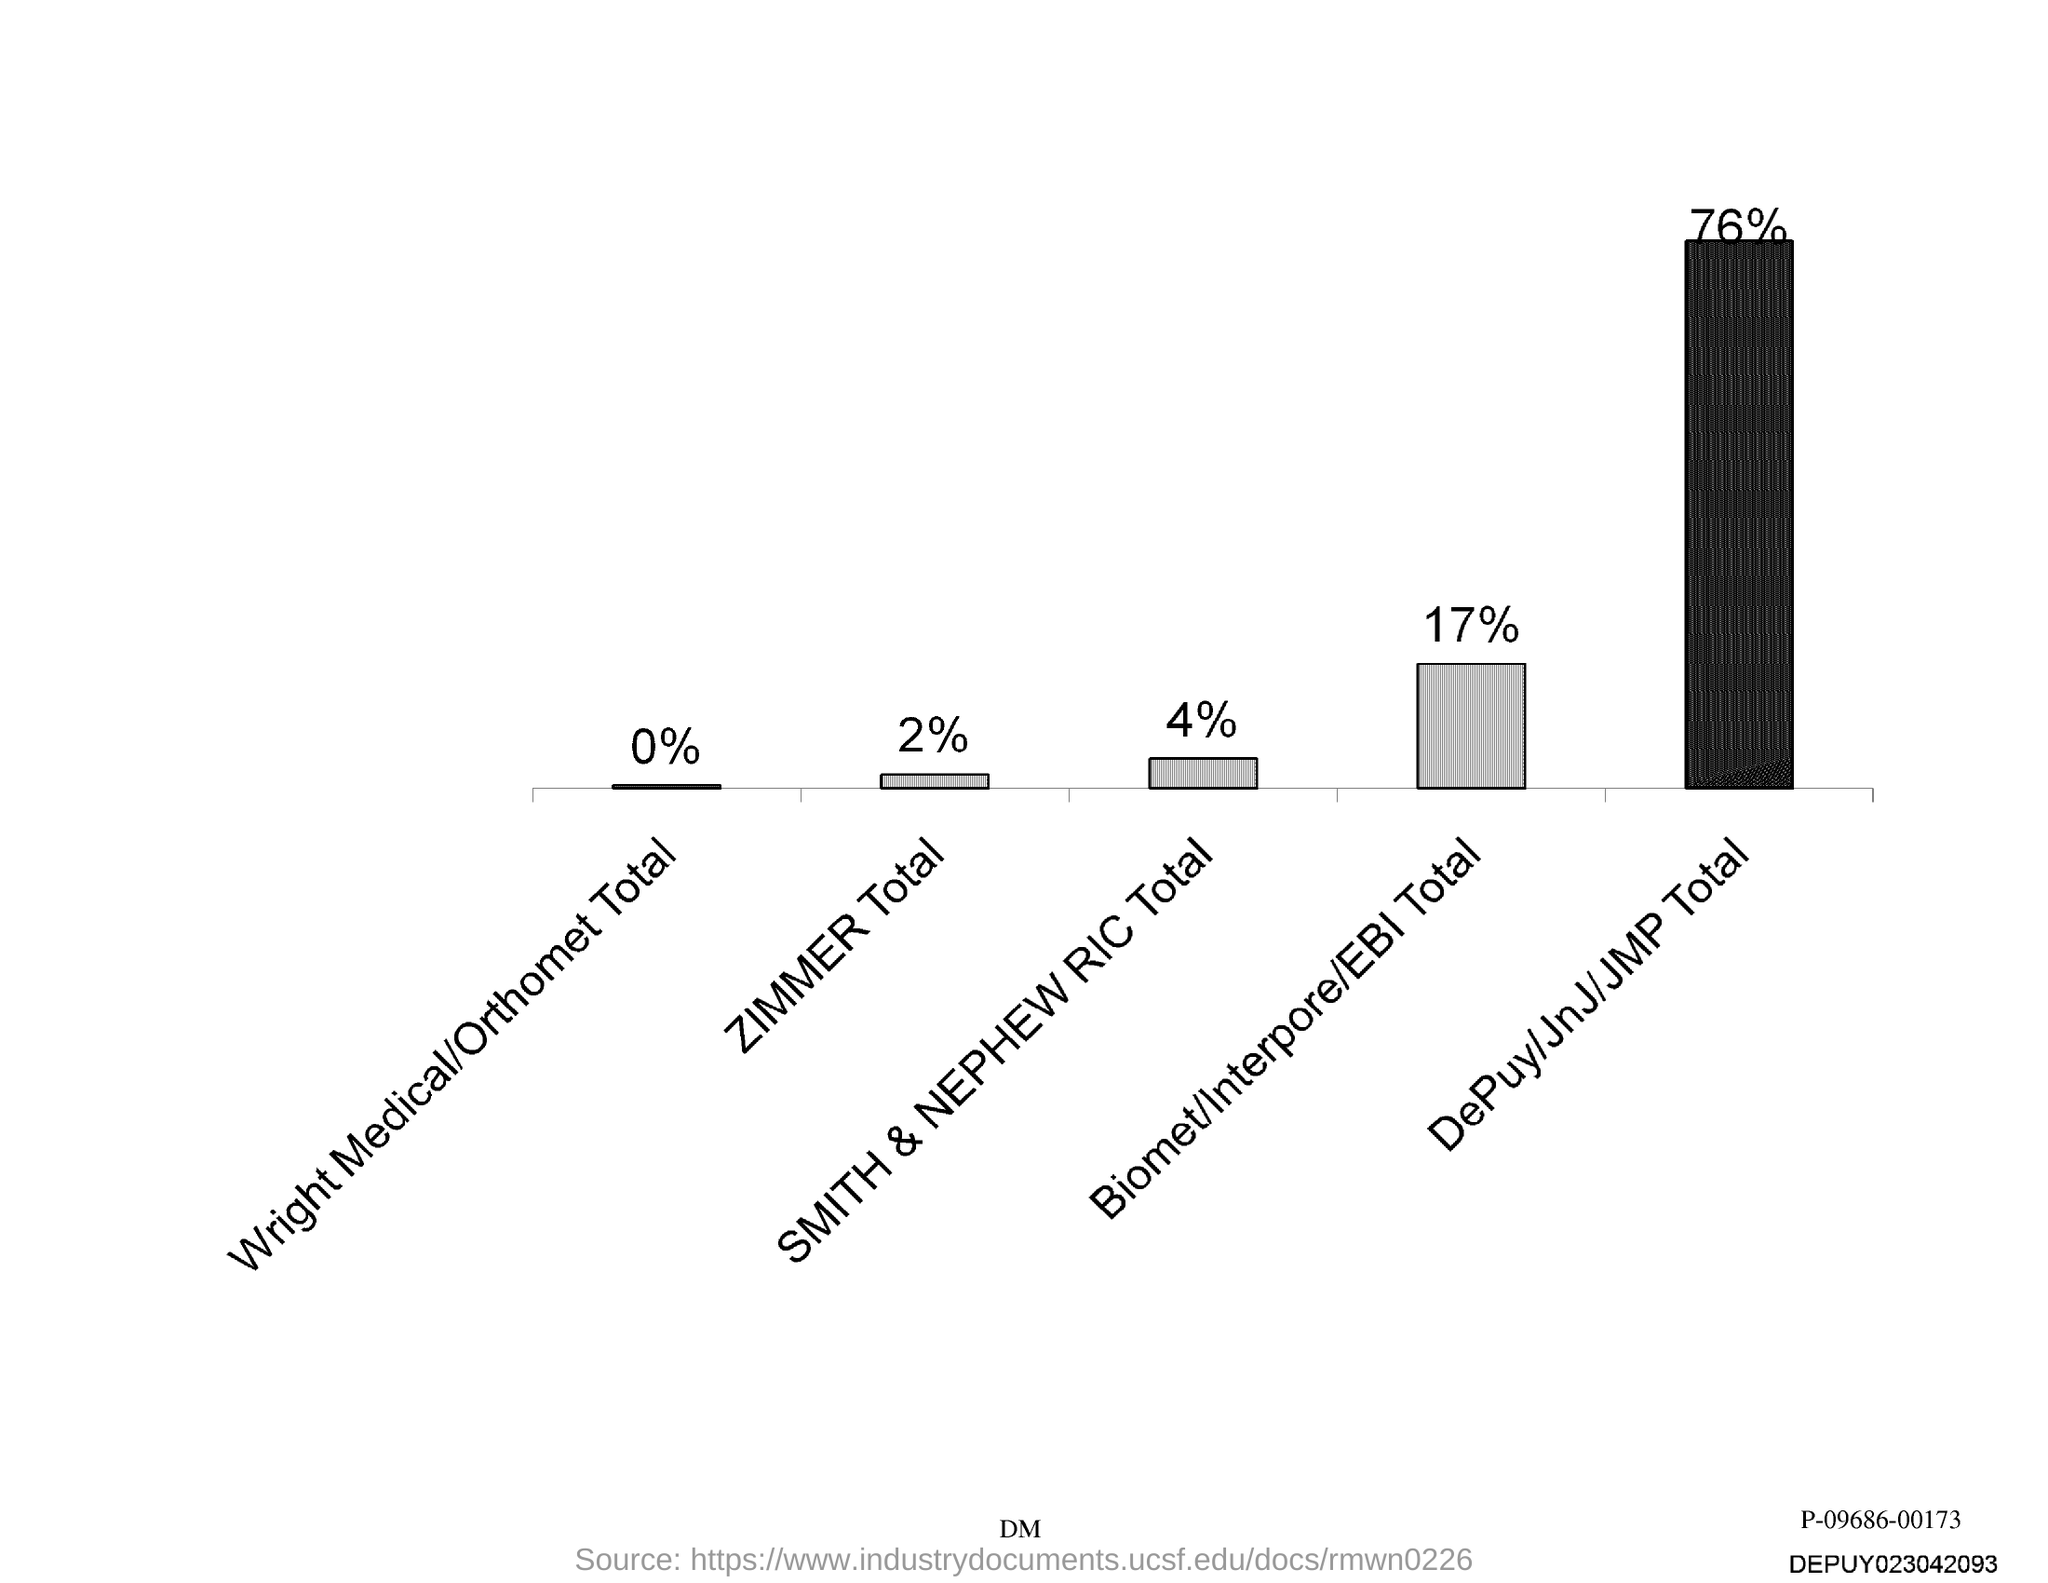The highest percentage is for which group?
Provide a succinct answer. DePuy/JnJ/JMP Total. The lowest percentage is for which group?
Offer a terse response. Wright Medical/Orthomet. What is the percentage of Zimmer?
Make the answer very short. 2%. What is the percentage of Smith & Nephew RIC?
Ensure brevity in your answer.  4%. 17% is for which group?
Your response must be concise. Biomet/Interpore/EBI. 